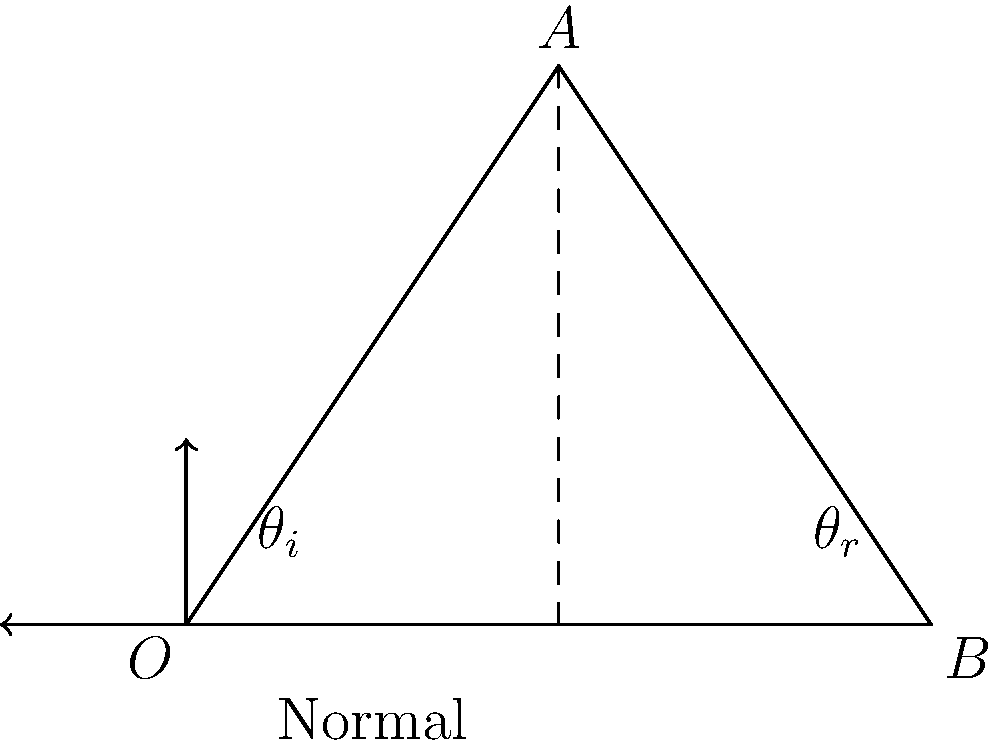In a 2D game physics simulation, an object bounces off a surface represented by line segment AB. The angle of incidence ($\theta_i$) is 30°. Calculate the angle of reflection ($\theta_r$) for the bouncing object. To solve this problem, we'll follow these steps:

1. Recall the law of reflection: The angle of incidence is equal to the angle of reflection.

2. In this case, the angle of incidence ($\theta_i$) is given as 30°.

3. The angle of reflection ($\theta_r$) will be equal to the angle of incidence:

   $\theta_r = \theta_i = 30°$

4. It's important to note that both angles are measured from the normal line (the line perpendicular to the reflecting surface) to the incident or reflected ray.

5. In game physics, you would typically use this angle to calculate the new velocity vector of the bouncing object:
   - Convert the angle to radians: $30° \times \frac{\pi}{180°} = \frac{\pi}{6}$ radians
   - Use trigonometric functions (sin and cos) with this angle to determine the x and y components of the new velocity vector

6. Remember to consider the direction of the normal vector of the surface when implementing this in your game, as it affects the final direction of the reflected object.
Answer: $30°$ 